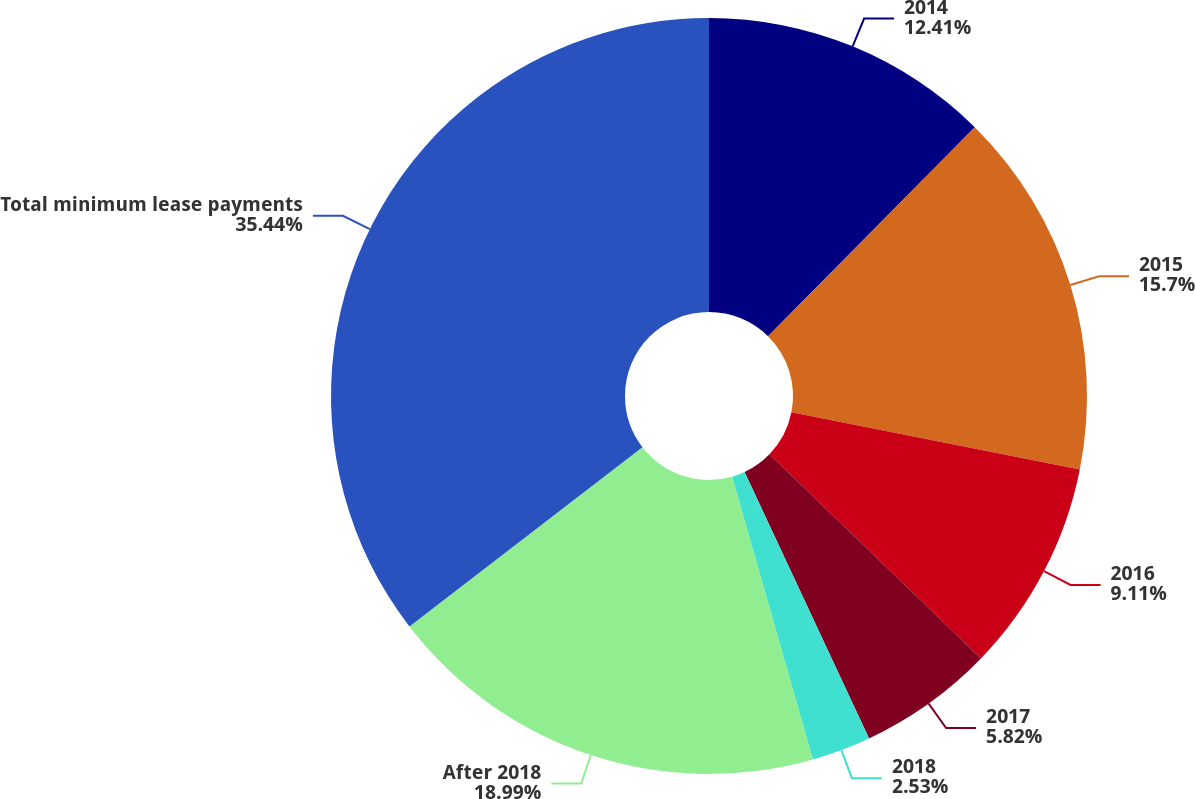Convert chart. <chart><loc_0><loc_0><loc_500><loc_500><pie_chart><fcel>2014<fcel>2015<fcel>2016<fcel>2017<fcel>2018<fcel>After 2018<fcel>Total minimum lease payments<nl><fcel>12.41%<fcel>15.7%<fcel>9.11%<fcel>5.82%<fcel>2.53%<fcel>18.99%<fcel>35.44%<nl></chart> 